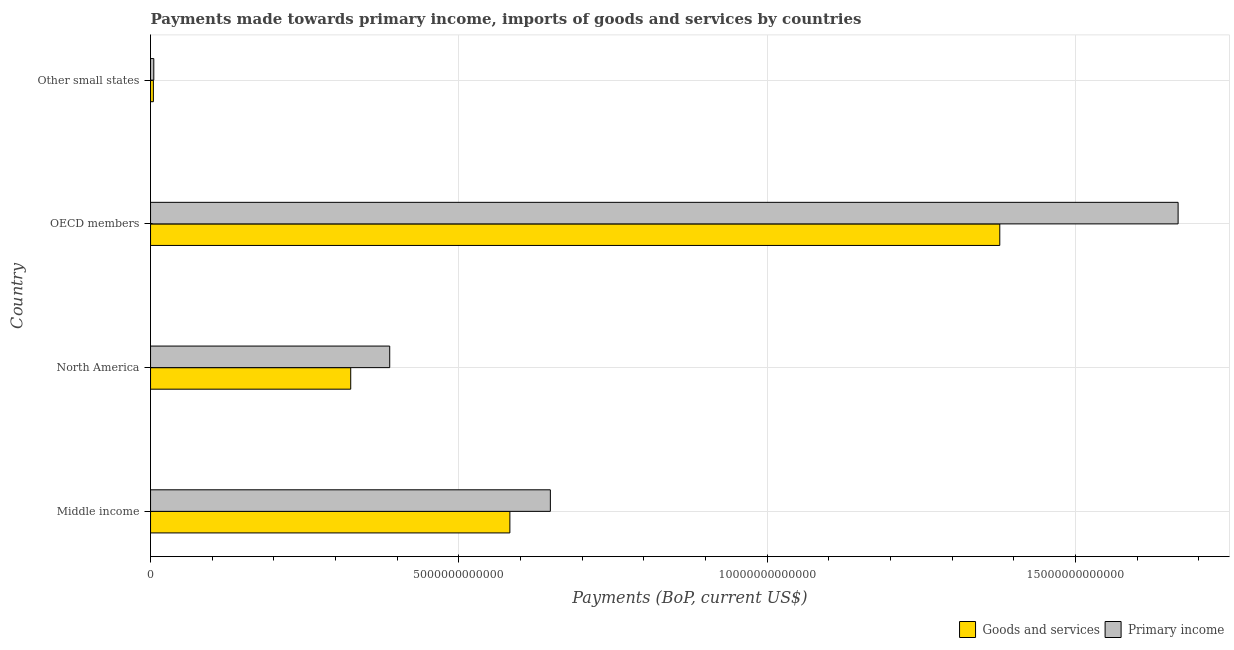How many groups of bars are there?
Your response must be concise. 4. Are the number of bars per tick equal to the number of legend labels?
Offer a very short reply. Yes. Are the number of bars on each tick of the Y-axis equal?
Offer a terse response. Yes. How many bars are there on the 1st tick from the bottom?
Your answer should be compact. 2. What is the label of the 1st group of bars from the top?
Give a very brief answer. Other small states. In how many cases, is the number of bars for a given country not equal to the number of legend labels?
Provide a succinct answer. 0. What is the payments made towards primary income in OECD members?
Ensure brevity in your answer.  1.67e+13. Across all countries, what is the maximum payments made towards primary income?
Your answer should be very brief. 1.67e+13. Across all countries, what is the minimum payments made towards primary income?
Offer a very short reply. 5.27e+1. In which country was the payments made towards primary income minimum?
Make the answer very short. Other small states. What is the total payments made towards primary income in the graph?
Your answer should be very brief. 2.71e+13. What is the difference between the payments made towards goods and services in Middle income and that in OECD members?
Keep it short and to the point. -7.94e+12. What is the difference between the payments made towards goods and services in Middle income and the payments made towards primary income in OECD members?
Offer a terse response. -1.08e+13. What is the average payments made towards goods and services per country?
Your answer should be very brief. 5.72e+12. What is the difference between the payments made towards primary income and payments made towards goods and services in Middle income?
Make the answer very short. 6.56e+11. In how many countries, is the payments made towards goods and services greater than 6000000000000 US$?
Provide a short and direct response. 1. What is the ratio of the payments made towards primary income in Middle income to that in Other small states?
Make the answer very short. 122.95. Is the payments made towards primary income in North America less than that in OECD members?
Offer a terse response. Yes. What is the difference between the highest and the second highest payments made towards goods and services?
Keep it short and to the point. 7.94e+12. What is the difference between the highest and the lowest payments made towards goods and services?
Offer a terse response. 1.37e+13. What does the 2nd bar from the top in North America represents?
Offer a very short reply. Goods and services. What does the 1st bar from the bottom in Middle income represents?
Offer a very short reply. Goods and services. How many bars are there?
Offer a very short reply. 8. Are all the bars in the graph horizontal?
Your response must be concise. Yes. How many countries are there in the graph?
Your response must be concise. 4. What is the difference between two consecutive major ticks on the X-axis?
Provide a short and direct response. 5.00e+12. How many legend labels are there?
Provide a succinct answer. 2. What is the title of the graph?
Your answer should be very brief. Payments made towards primary income, imports of goods and services by countries. What is the label or title of the X-axis?
Your response must be concise. Payments (BoP, current US$). What is the label or title of the Y-axis?
Offer a terse response. Country. What is the Payments (BoP, current US$) of Goods and services in Middle income?
Your answer should be very brief. 5.83e+12. What is the Payments (BoP, current US$) in Primary income in Middle income?
Your answer should be compact. 6.48e+12. What is the Payments (BoP, current US$) in Goods and services in North America?
Your response must be concise. 3.25e+12. What is the Payments (BoP, current US$) in Primary income in North America?
Make the answer very short. 3.88e+12. What is the Payments (BoP, current US$) in Goods and services in OECD members?
Your answer should be very brief. 1.38e+13. What is the Payments (BoP, current US$) of Primary income in OECD members?
Your answer should be compact. 1.67e+13. What is the Payments (BoP, current US$) in Goods and services in Other small states?
Your answer should be compact. 4.59e+1. What is the Payments (BoP, current US$) of Primary income in Other small states?
Give a very brief answer. 5.27e+1. Across all countries, what is the maximum Payments (BoP, current US$) of Goods and services?
Provide a short and direct response. 1.38e+13. Across all countries, what is the maximum Payments (BoP, current US$) in Primary income?
Your answer should be compact. 1.67e+13. Across all countries, what is the minimum Payments (BoP, current US$) in Goods and services?
Offer a terse response. 4.59e+1. Across all countries, what is the minimum Payments (BoP, current US$) in Primary income?
Offer a very short reply. 5.27e+1. What is the total Payments (BoP, current US$) of Goods and services in the graph?
Offer a terse response. 2.29e+13. What is the total Payments (BoP, current US$) in Primary income in the graph?
Your answer should be very brief. 2.71e+13. What is the difference between the Payments (BoP, current US$) in Goods and services in Middle income and that in North America?
Offer a very short reply. 2.58e+12. What is the difference between the Payments (BoP, current US$) in Primary income in Middle income and that in North America?
Make the answer very short. 2.60e+12. What is the difference between the Payments (BoP, current US$) of Goods and services in Middle income and that in OECD members?
Your answer should be compact. -7.94e+12. What is the difference between the Payments (BoP, current US$) of Primary income in Middle income and that in OECD members?
Give a very brief answer. -1.02e+13. What is the difference between the Payments (BoP, current US$) of Goods and services in Middle income and that in Other small states?
Provide a short and direct response. 5.78e+12. What is the difference between the Payments (BoP, current US$) of Primary income in Middle income and that in Other small states?
Provide a short and direct response. 6.43e+12. What is the difference between the Payments (BoP, current US$) in Goods and services in North America and that in OECD members?
Provide a succinct answer. -1.05e+13. What is the difference between the Payments (BoP, current US$) of Primary income in North America and that in OECD members?
Your answer should be very brief. -1.28e+13. What is the difference between the Payments (BoP, current US$) in Goods and services in North America and that in Other small states?
Your answer should be compact. 3.20e+12. What is the difference between the Payments (BoP, current US$) of Primary income in North America and that in Other small states?
Make the answer very short. 3.83e+12. What is the difference between the Payments (BoP, current US$) of Goods and services in OECD members and that in Other small states?
Your answer should be very brief. 1.37e+13. What is the difference between the Payments (BoP, current US$) in Primary income in OECD members and that in Other small states?
Ensure brevity in your answer.  1.66e+13. What is the difference between the Payments (BoP, current US$) in Goods and services in Middle income and the Payments (BoP, current US$) in Primary income in North America?
Your answer should be compact. 1.95e+12. What is the difference between the Payments (BoP, current US$) of Goods and services in Middle income and the Payments (BoP, current US$) of Primary income in OECD members?
Provide a succinct answer. -1.08e+13. What is the difference between the Payments (BoP, current US$) of Goods and services in Middle income and the Payments (BoP, current US$) of Primary income in Other small states?
Your answer should be very brief. 5.77e+12. What is the difference between the Payments (BoP, current US$) in Goods and services in North America and the Payments (BoP, current US$) in Primary income in OECD members?
Ensure brevity in your answer.  -1.34e+13. What is the difference between the Payments (BoP, current US$) of Goods and services in North America and the Payments (BoP, current US$) of Primary income in Other small states?
Give a very brief answer. 3.19e+12. What is the difference between the Payments (BoP, current US$) of Goods and services in OECD members and the Payments (BoP, current US$) of Primary income in Other small states?
Provide a short and direct response. 1.37e+13. What is the average Payments (BoP, current US$) in Goods and services per country?
Provide a short and direct response. 5.72e+12. What is the average Payments (BoP, current US$) in Primary income per country?
Give a very brief answer. 6.77e+12. What is the difference between the Payments (BoP, current US$) in Goods and services and Payments (BoP, current US$) in Primary income in Middle income?
Give a very brief answer. -6.56e+11. What is the difference between the Payments (BoP, current US$) in Goods and services and Payments (BoP, current US$) in Primary income in North America?
Keep it short and to the point. -6.32e+11. What is the difference between the Payments (BoP, current US$) in Goods and services and Payments (BoP, current US$) in Primary income in OECD members?
Your answer should be very brief. -2.89e+12. What is the difference between the Payments (BoP, current US$) of Goods and services and Payments (BoP, current US$) of Primary income in Other small states?
Make the answer very short. -6.81e+09. What is the ratio of the Payments (BoP, current US$) of Goods and services in Middle income to that in North America?
Keep it short and to the point. 1.8. What is the ratio of the Payments (BoP, current US$) in Primary income in Middle income to that in North America?
Give a very brief answer. 1.67. What is the ratio of the Payments (BoP, current US$) of Goods and services in Middle income to that in OECD members?
Provide a short and direct response. 0.42. What is the ratio of the Payments (BoP, current US$) in Primary income in Middle income to that in OECD members?
Give a very brief answer. 0.39. What is the ratio of the Payments (BoP, current US$) of Goods and services in Middle income to that in Other small states?
Give a very brief answer. 126.88. What is the ratio of the Payments (BoP, current US$) in Primary income in Middle income to that in Other small states?
Your response must be concise. 122.95. What is the ratio of the Payments (BoP, current US$) of Goods and services in North America to that in OECD members?
Offer a terse response. 0.24. What is the ratio of the Payments (BoP, current US$) of Primary income in North America to that in OECD members?
Your answer should be compact. 0.23. What is the ratio of the Payments (BoP, current US$) of Goods and services in North America to that in Other small states?
Your answer should be compact. 70.68. What is the ratio of the Payments (BoP, current US$) of Primary income in North America to that in Other small states?
Provide a short and direct response. 73.55. What is the ratio of the Payments (BoP, current US$) of Goods and services in OECD members to that in Other small states?
Provide a succinct answer. 299.87. What is the ratio of the Payments (BoP, current US$) in Primary income in OECD members to that in Other small states?
Your response must be concise. 315.99. What is the difference between the highest and the second highest Payments (BoP, current US$) of Goods and services?
Your answer should be very brief. 7.94e+12. What is the difference between the highest and the second highest Payments (BoP, current US$) of Primary income?
Keep it short and to the point. 1.02e+13. What is the difference between the highest and the lowest Payments (BoP, current US$) of Goods and services?
Keep it short and to the point. 1.37e+13. What is the difference between the highest and the lowest Payments (BoP, current US$) of Primary income?
Your answer should be compact. 1.66e+13. 